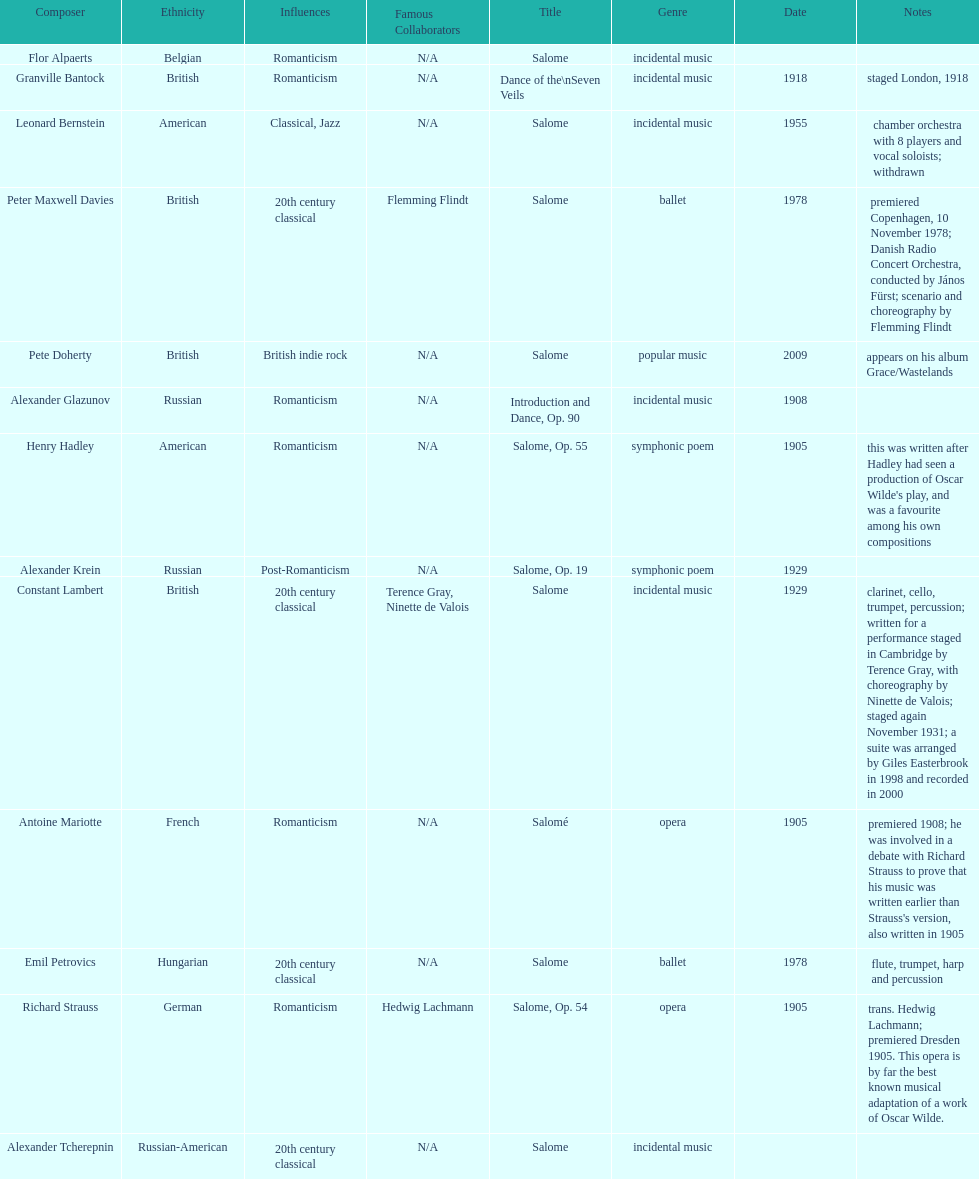Why type of genre was peter maxwell davies' work that was the same as emil petrovics' Ballet. 